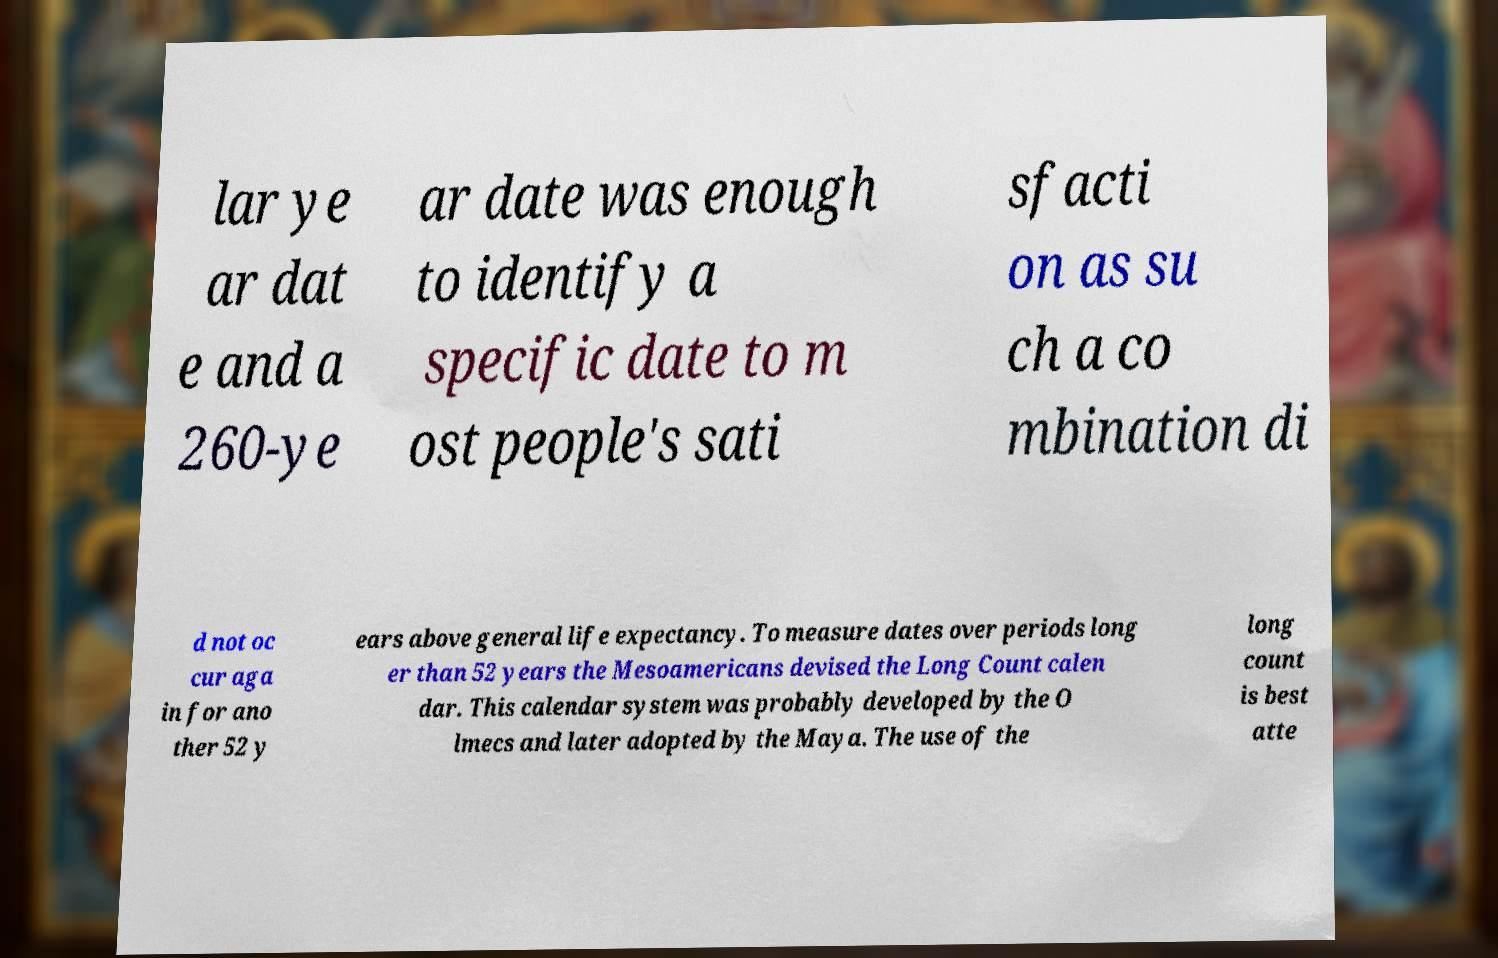Can you accurately transcribe the text from the provided image for me? lar ye ar dat e and a 260-ye ar date was enough to identify a specific date to m ost people's sati sfacti on as su ch a co mbination di d not oc cur aga in for ano ther 52 y ears above general life expectancy. To measure dates over periods long er than 52 years the Mesoamericans devised the Long Count calen dar. This calendar system was probably developed by the O lmecs and later adopted by the Maya. The use of the long count is best atte 